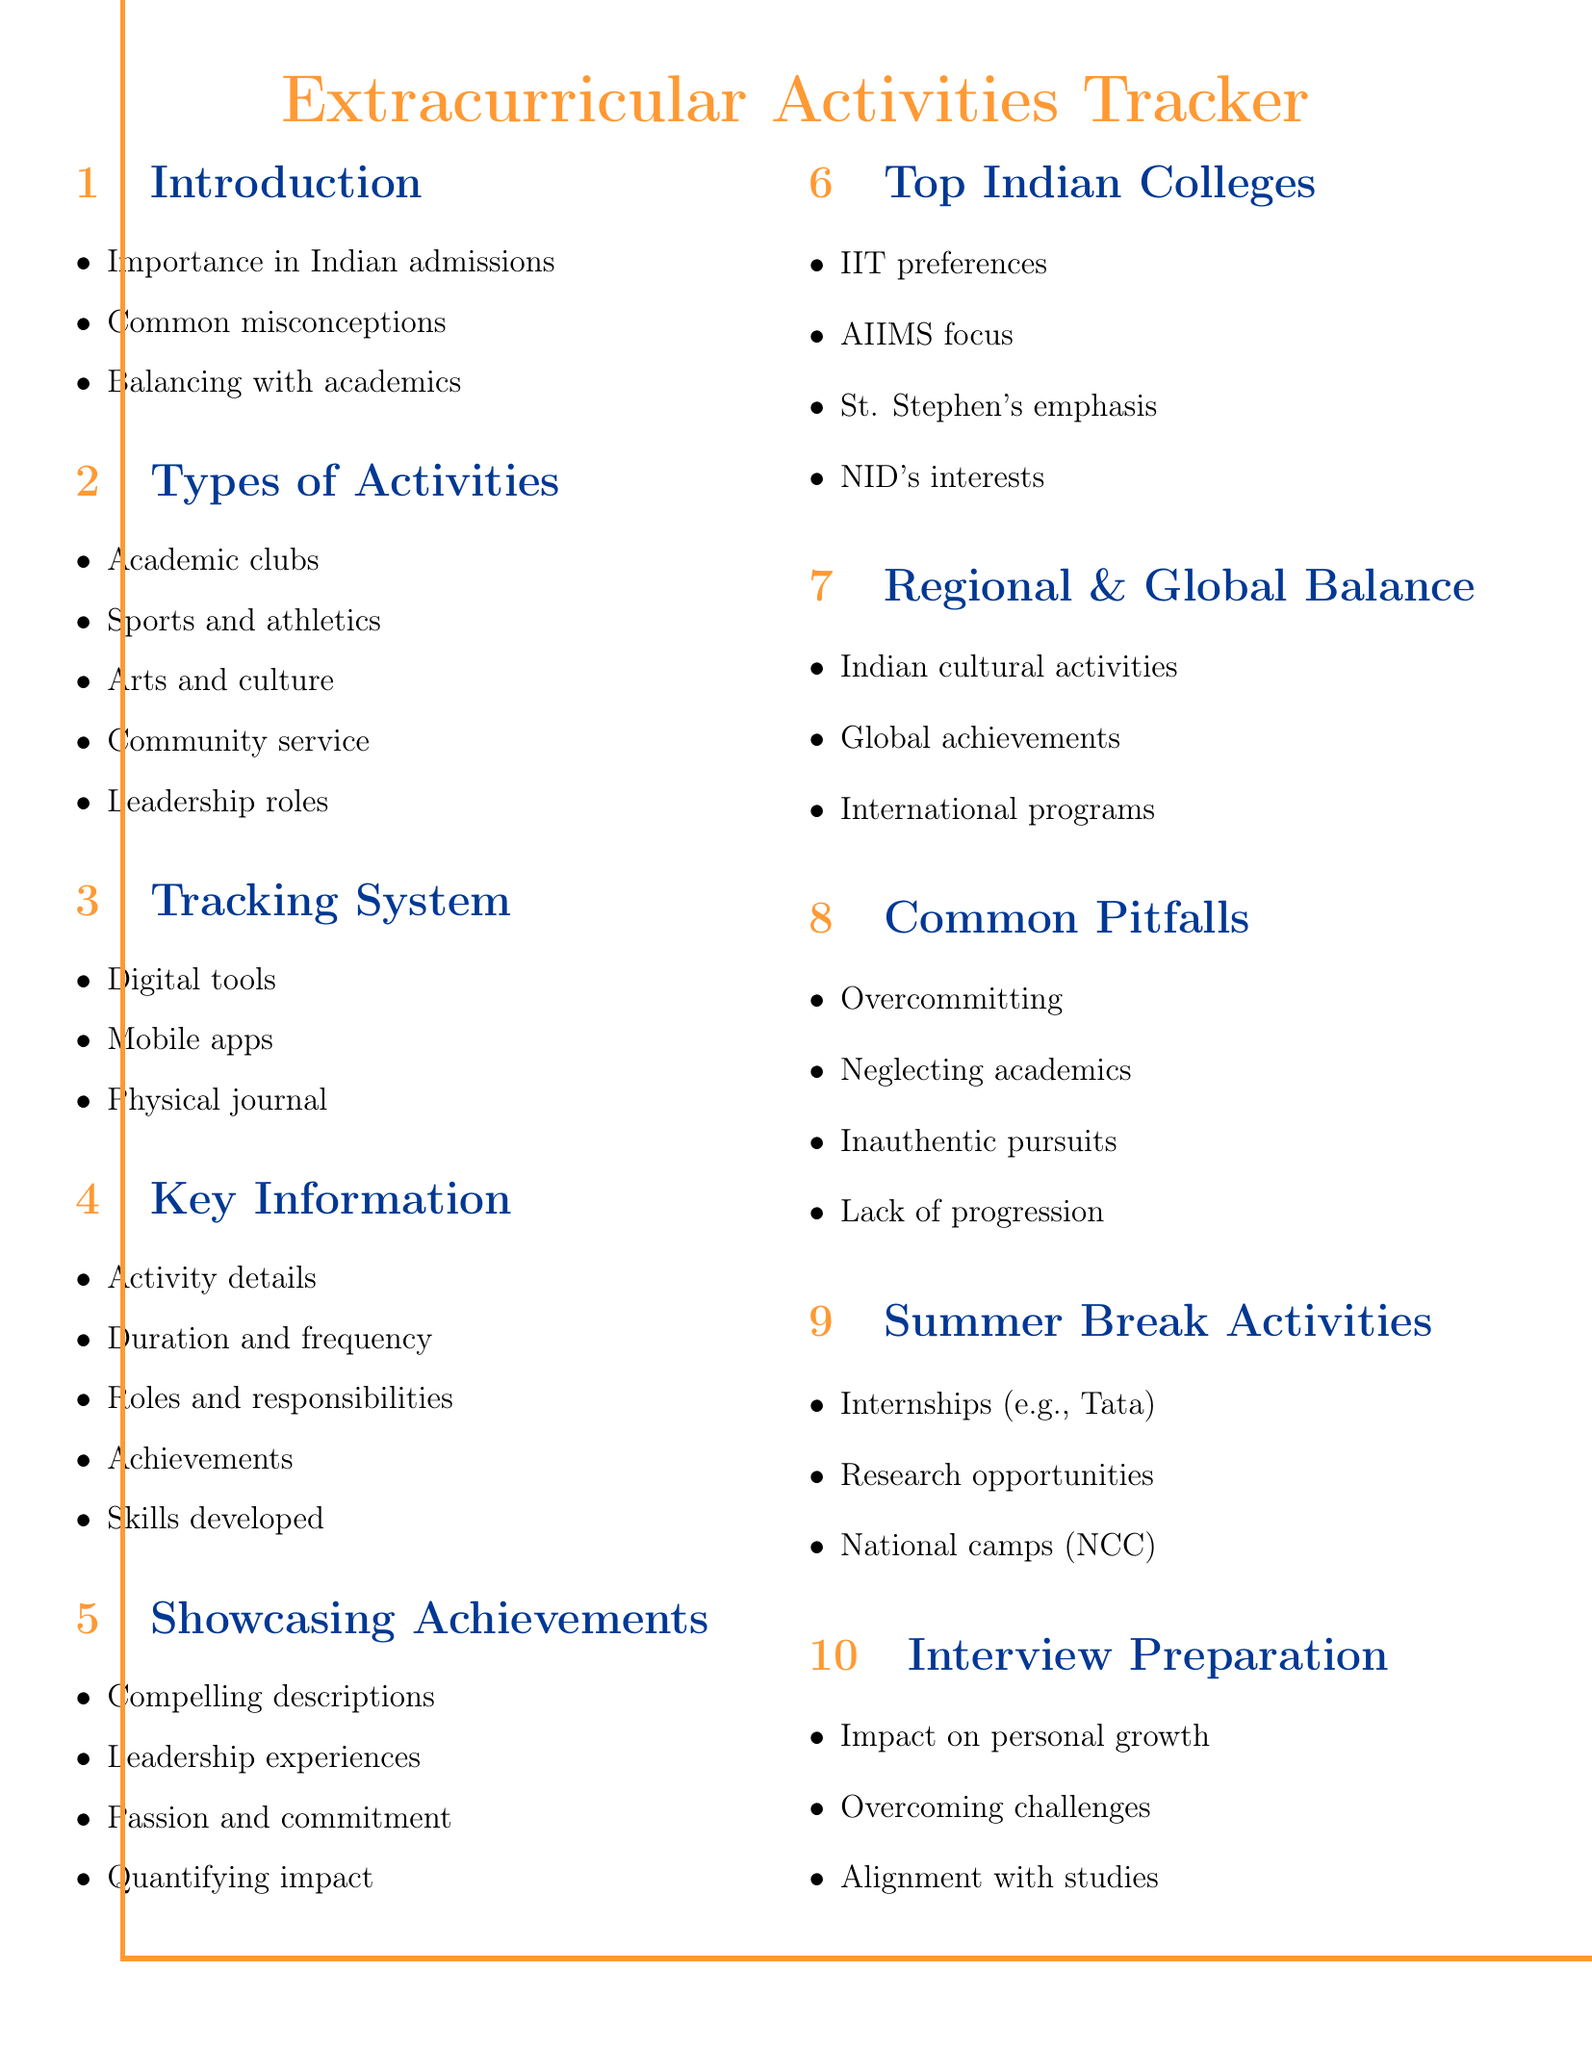What is the first agenda item? The first agenda item is "Introduction to Extracurricular Activities Tracking" in the document structure.
Answer: Introduction to Extracurricular Activities Tracking Which college emphasizes well-rounded profiles? St. Stephen's College is noted for its emphasis on well-rounded profiles as per the document.
Answer: St. Stephen's College How many types of extracurricular activities are listed? The document outlines a total of five types of extracurricular activities under the "Types of Activities" section.
Answer: Five What is one digital tool mentioned for tracking activities? The document specifies Google Sheets as a digital tool for tracking extracurricular activities.
Answer: Google Sheets What is a common pitfall to avoid according to the document? The document suggests that "Overcommitting to too many activities" is a common pitfall to avoid.
Answer: Overcommitting to too many activities Which type of activities does IIT prefer? IIT preferences are noted to be related to technical and innovation-related activities.
Answer: Technical and innovation-related activities What should be quantified when showcasing achievements? The document states that "impact and results" should be quantified when showcasing achievements in college applications.
Answer: Impact and results What is one way to leverage summer breaks for extracurricular activities? The document mentions participating in national camps like NCC as a way to leverage summer breaks.
Answer: National camps (NCC) 